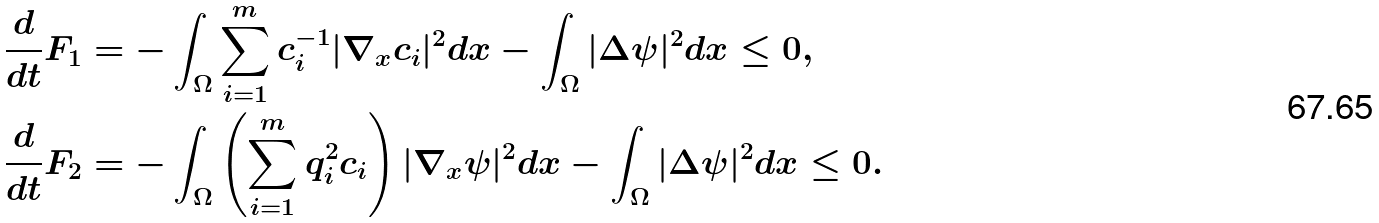Convert formula to latex. <formula><loc_0><loc_0><loc_500><loc_500>\frac { d } { d t } F _ { 1 } & = - \int _ { \Omega } \sum _ { i = 1 } ^ { m } c _ { i } ^ { - 1 } | \nabla _ { x } c _ { i } | ^ { 2 } d x - \int _ { \Omega } | \Delta \psi | ^ { 2 } d x \leq 0 , \\ \frac { d } { d t } F _ { 2 } & = - \int _ { \Omega } \left ( \sum _ { i = 1 } ^ { m } q _ { i } ^ { 2 } c _ { i } \right ) | \nabla _ { x } \psi | ^ { 2 } d x - \int _ { \Omega } | \Delta \psi | ^ { 2 } d x \leq 0 .</formula> 